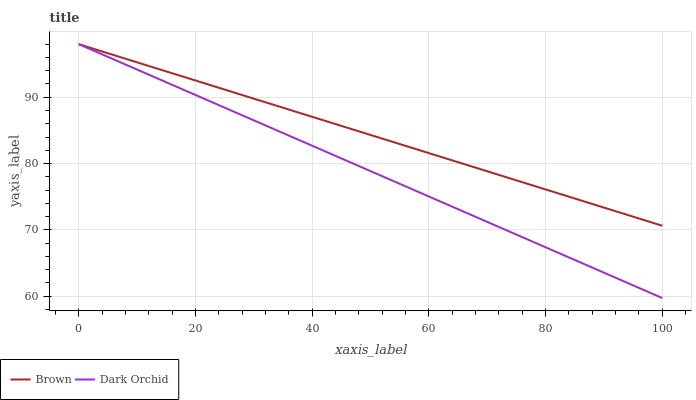Does Dark Orchid have the minimum area under the curve?
Answer yes or no. Yes. Does Brown have the maximum area under the curve?
Answer yes or no. Yes. Does Dark Orchid have the maximum area under the curve?
Answer yes or no. No. Is Brown the smoothest?
Answer yes or no. Yes. Is Dark Orchid the roughest?
Answer yes or no. Yes. Is Dark Orchid the smoothest?
Answer yes or no. No. Does Dark Orchid have the highest value?
Answer yes or no. Yes. Does Dark Orchid intersect Brown?
Answer yes or no. Yes. Is Dark Orchid less than Brown?
Answer yes or no. No. Is Dark Orchid greater than Brown?
Answer yes or no. No. 